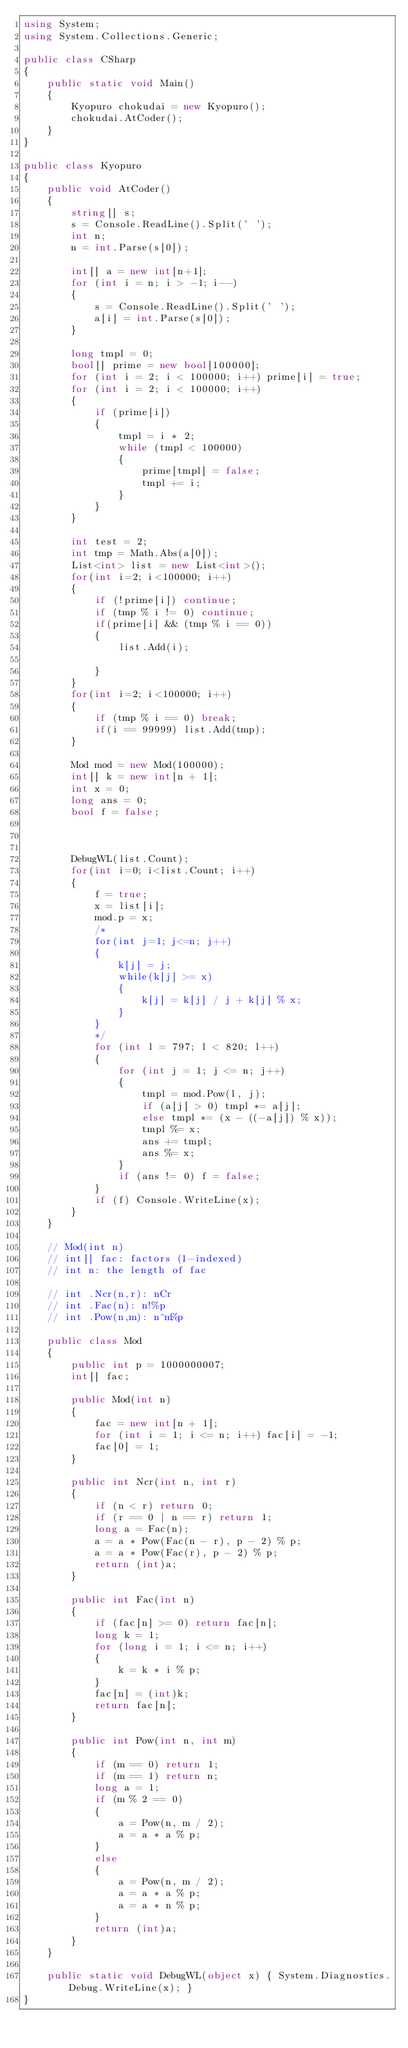<code> <loc_0><loc_0><loc_500><loc_500><_C#_>using System;
using System.Collections.Generic;

public class CSharp
{
    public static void Main()
    {
        Kyopuro chokudai = new Kyopuro();
        chokudai.AtCoder();
    }
}

public class Kyopuro
{
    public void AtCoder()
    {
        string[] s;
        s = Console.ReadLine().Split(' ');
        int n;
        n = int.Parse(s[0]);

        int[] a = new int[n+1];
        for (int i = n; i > -1; i--)
        {
            s = Console.ReadLine().Split(' ');
            a[i] = int.Parse(s[0]);
        }

        long tmpl = 0;
        bool[] prime = new bool[100000];
        for (int i = 2; i < 100000; i++) prime[i] = true;
        for (int i = 2; i < 100000; i++)
        {
            if (prime[i])
            {
                tmpl = i * 2;
                while (tmpl < 100000)
                {
                    prime[tmpl] = false;
                    tmpl += i;
                }
            }
        }

        int test = 2;
        int tmp = Math.Abs(a[0]);
        List<int> list = new List<int>();
        for(int i=2; i<100000; i++)
        {
            if (!prime[i]) continue;
            if (tmp % i != 0) continue;
            if(prime[i] && (tmp % i == 0))
            {
                list.Add(i);
                
            }
        }
        for(int i=2; i<100000; i++)
        {
            if (tmp % i == 0) break;
            if(i == 99999) list.Add(tmp);
        }

        Mod mod = new Mod(100000);
        int[] k = new int[n + 1];
        int x = 0;
        long ans = 0;
        bool f = false;

        
        
        DebugWL(list.Count);
        for(int i=0; i<list.Count; i++)
        {
            f = true;
            x = list[i];
            mod.p = x;
            /*
            for(int j=1; j<=n; j++)
            {
                k[j] = j;
                while(k[j] >= x)
                {
                    k[j] = k[j] / j + k[j] % x;
                }
            }
            */
            for (int l = 797; l < 820; l++)
            {
                for (int j = 1; j <= n; j++)
                {
                    tmpl = mod.Pow(l, j);
                    if (a[j] > 0) tmpl *= a[j];
                    else tmpl *= (x - ((-a[j]) % x));
                    tmpl %= x;
                    ans += tmpl;
                    ans %= x;                                
                }
                if (ans != 0) f = false;
            }
            if (f) Console.WriteLine(x);
        }
    }

    // Mod(int n)
    // int[] fac: factors (1-indexed)
    // int n: the length of fac

    // int .Ncr(n,r): nCr
    // int .Fac(n): n!%p
    // int .Pow(n,m): n^m%p

    public class Mod
    {
        public int p = 1000000007;
        int[] fac;

        public Mod(int n)
        {
            fac = new int[n + 1];
            for (int i = 1; i <= n; i++) fac[i] = -1;
            fac[0] = 1;
        }

        public int Ncr(int n, int r)
        {
            if (n < r) return 0;
            if (r == 0 | n == r) return 1;
            long a = Fac(n);
            a = a * Pow(Fac(n - r), p - 2) % p;
            a = a * Pow(Fac(r), p - 2) % p;
            return (int)a;
        }

        public int Fac(int n)
        {
            if (fac[n] >= 0) return fac[n];
            long k = 1;
            for (long i = 1; i <= n; i++)
            {
                k = k * i % p;
            }
            fac[n] = (int)k;
            return fac[n];
        }

        public int Pow(int n, int m)
        {
            if (m == 0) return 1;
            if (m == 1) return n;
            long a = 1;
            if (m % 2 == 0)
            {
                a = Pow(n, m / 2);
                a = a * a % p;
            }
            else
            {
                a = Pow(n, m / 2);
                a = a * a % p;
                a = a * n % p;
            }
            return (int)a;
        }
    }

    public static void DebugWL(object x) { System.Diagnostics.Debug.WriteLine(x); }
}
</code> 